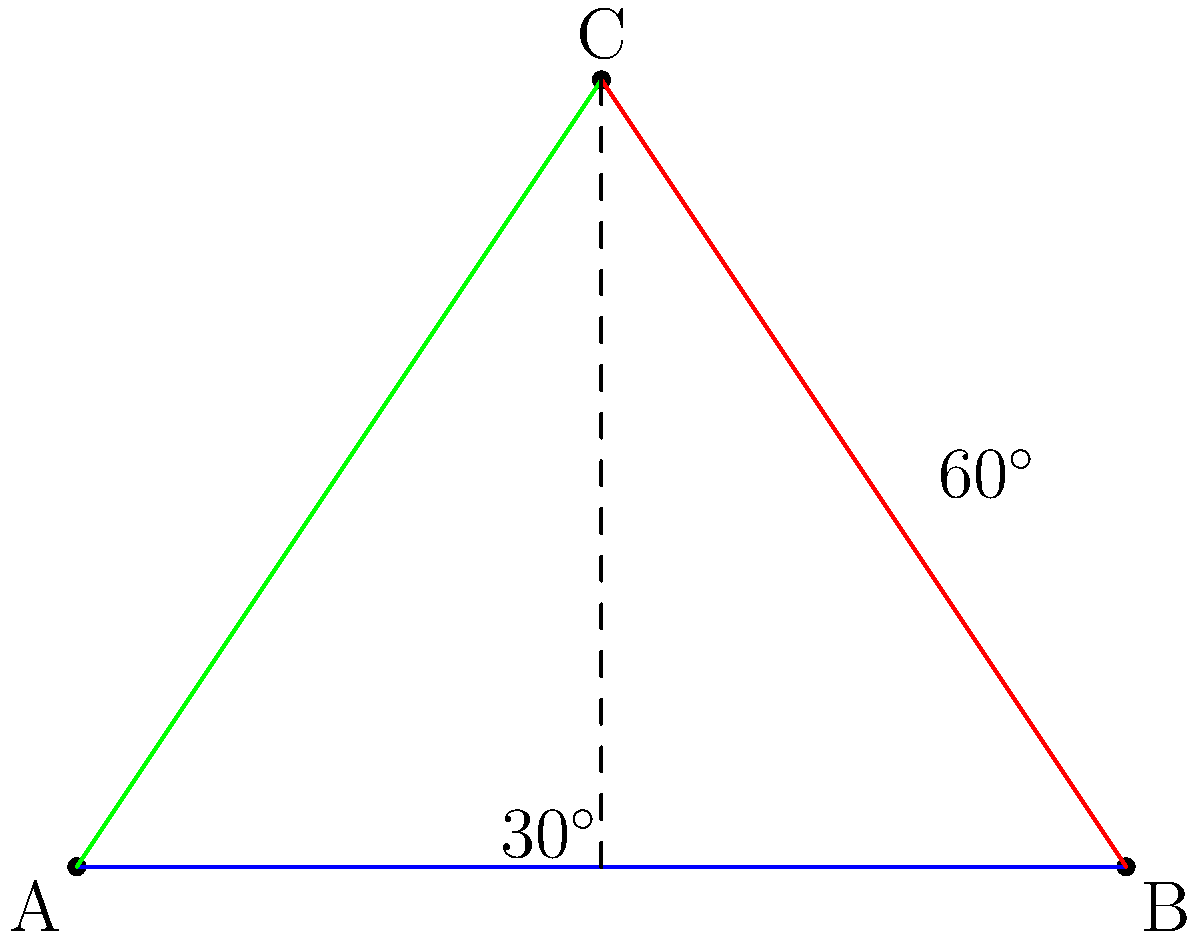In this ancient astronomical diagram representing celestial alignments, angle BAC measures 30°. What is the measure of angle BCA? To solve this problem, let's follow these steps:

1. Recognize that the diagram shows a triangle ABC.

2. We are given that angle BAC = 30°.

3. In any triangle, the sum of all interior angles is always 180°.

4. We can see that the diagram shows angle ABC as 90° (a right angle).

5. Let x be the measure of angle BCA.

6. We can now set up an equation based on the sum of angles in a triangle:
   
   $30^\circ + 90^\circ + x = 180^\circ$

7. Simplify:
   
   $120^\circ + x = 180^\circ$

8. Subtract 120° from both sides:
   
   $x = 60^\circ$

Therefore, the measure of angle BCA is 60°.
Answer: 60° 